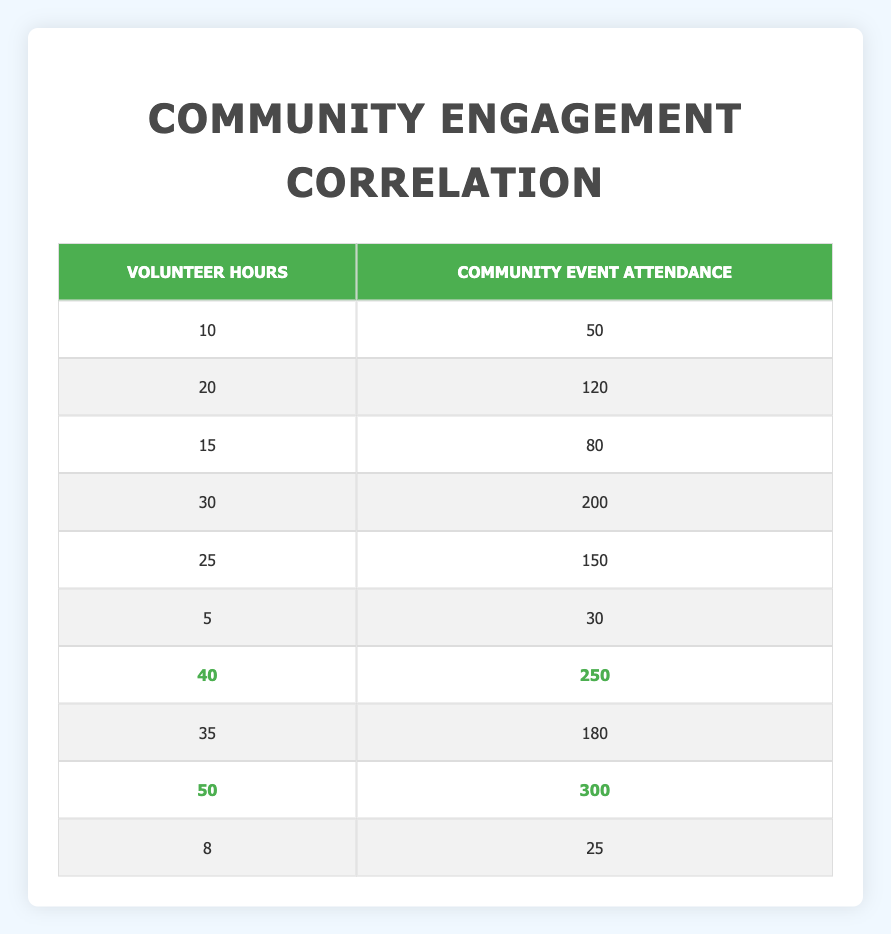What is the total Community Event Attendance for volunteers who contributed at least 25 hours? To find the total Community Event Attendance for volunteers with at least 25 hours, first identify those rows: 25 hours (150 attendees), 30 hours (200 attendees), 40 hours (250 attendees), and 50 hours (300 attendees). Then, sum these attendance numbers: 150 + 200 + 250 + 300 = 900.
Answer: 900 What is the highest number of Volunteer Hours recorded in the table? Looking across the Volunteer Hours column, the highest value is 50 hours, which is clearly shown in the relevant row.
Answer: 50 Is there a volunteer who contributed 5 hours that had more than 50 attendees at the community event? Referring to the row where Volunteer Hours are 5, the corresponding Community Event Attendance is 30. Since 30 is not greater than 50, the answer is no.
Answer: No What is the average Community Event Attendance for volunteers who worked less than 20 hours? Identify the relevant rows with Volunteer Hours less than 20: 10 hours (50 attendees), 15 hours (80 attendees), and 5 hours (30 attendees). Next, sum the attendance: 50 + 80 + 30 = 160, and then divide by the number of entries (3): 160/3 = approximately 53.33.
Answer: 53.33 How does Volunteer Hours correlate with Community Event Attendance based on the highest values in both categories? The highest Volunteer Hours is 50 (300 attendees) followed by 40 (250 attendees) and 35 (180 attendees). The pattern shows that as volunteer hours increase, community event attendance also tends to rise significantly, indicating a positive correlation.
Answer: Positive correlation 